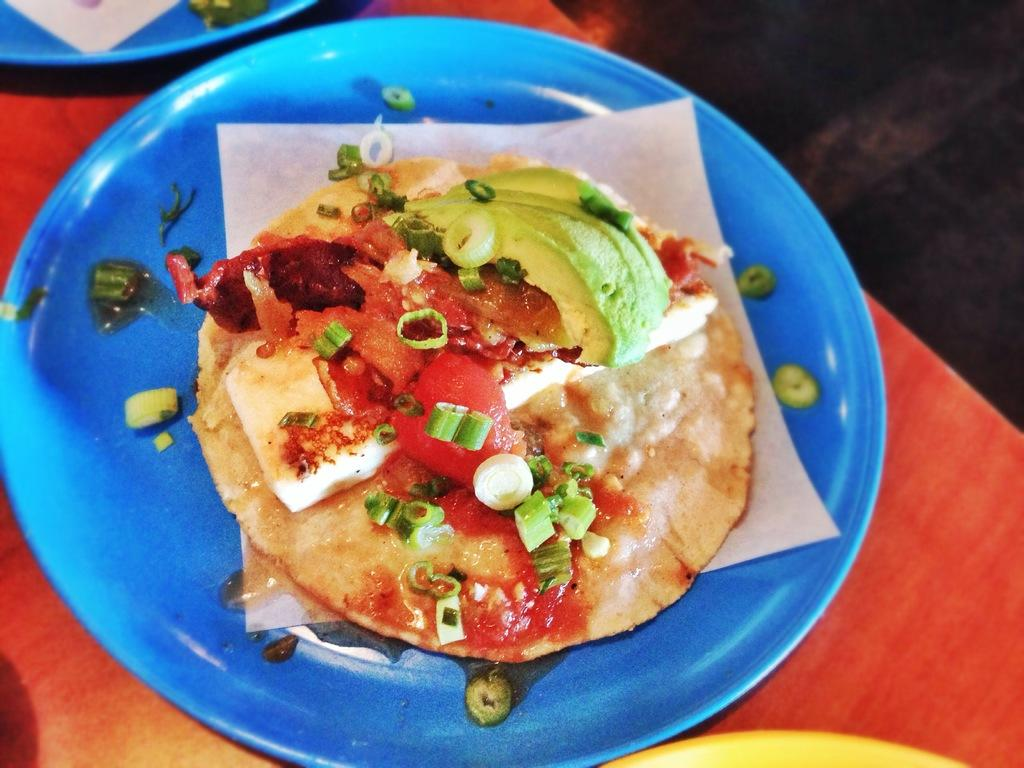What is the main subject of the image? The main subject of the image is food. How is the food presented in the image? The food is placed on a paper and in a plate. Where is the plate with food located? The plate with food is on a table. Can you see a yak grazing in the background of the image? There is no yak present in the image. What type of bun is being served with the food in the image? The image does not show any specific type of bun being served with the food. 